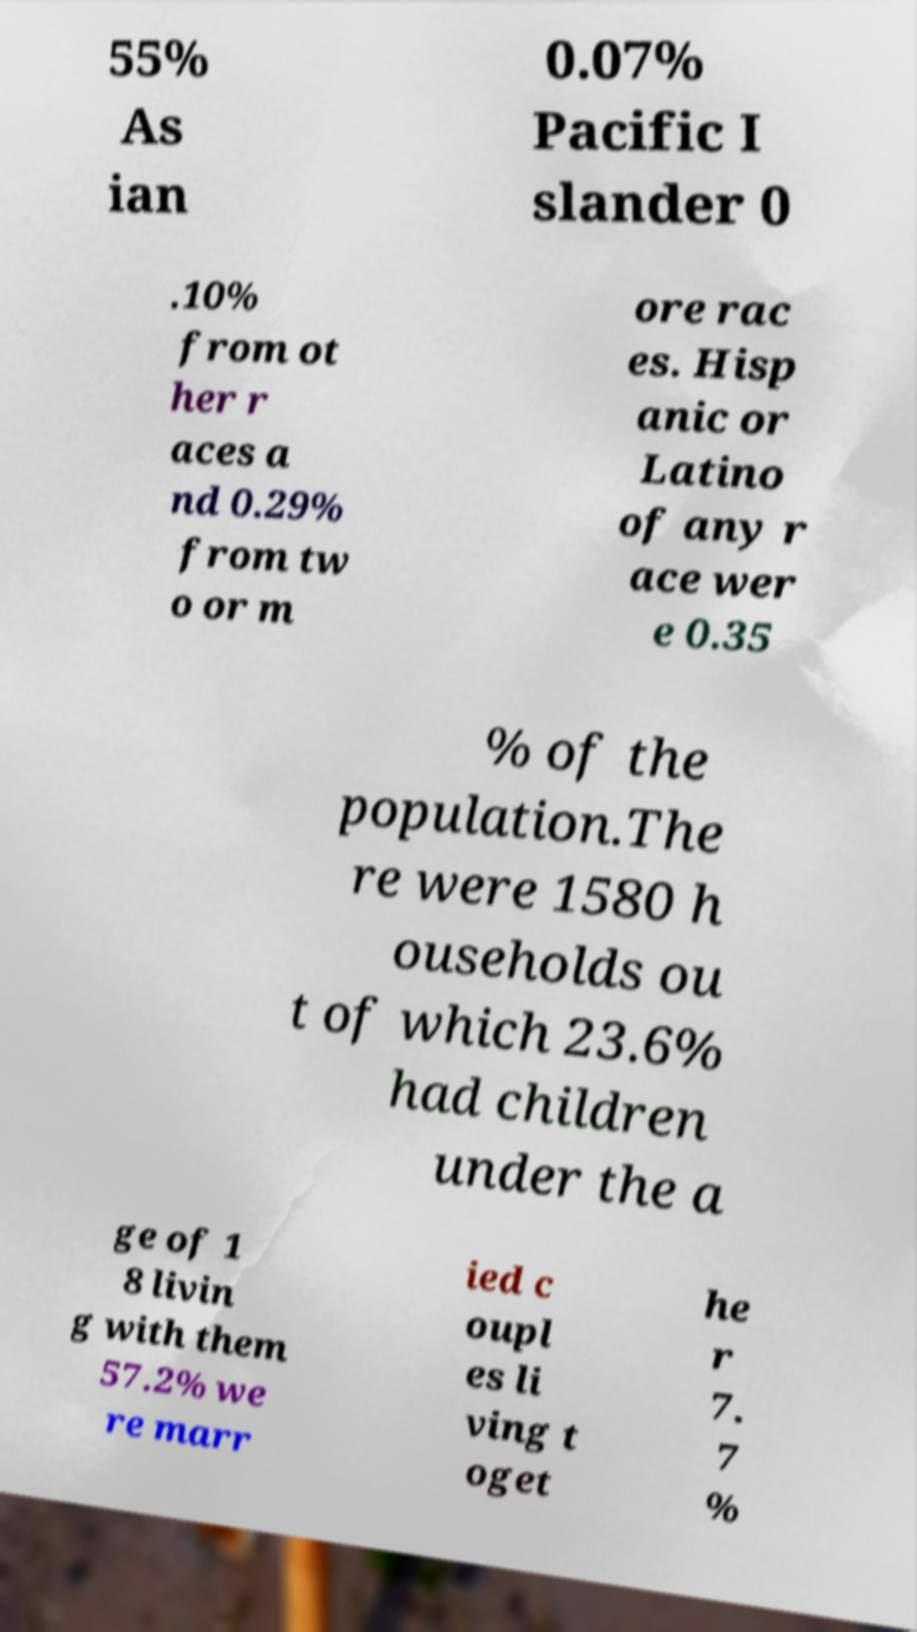I need the written content from this picture converted into text. Can you do that? 55% As ian 0.07% Pacific I slander 0 .10% from ot her r aces a nd 0.29% from tw o or m ore rac es. Hisp anic or Latino of any r ace wer e 0.35 % of the population.The re were 1580 h ouseholds ou t of which 23.6% had children under the a ge of 1 8 livin g with them 57.2% we re marr ied c oupl es li ving t oget he r 7. 7 % 